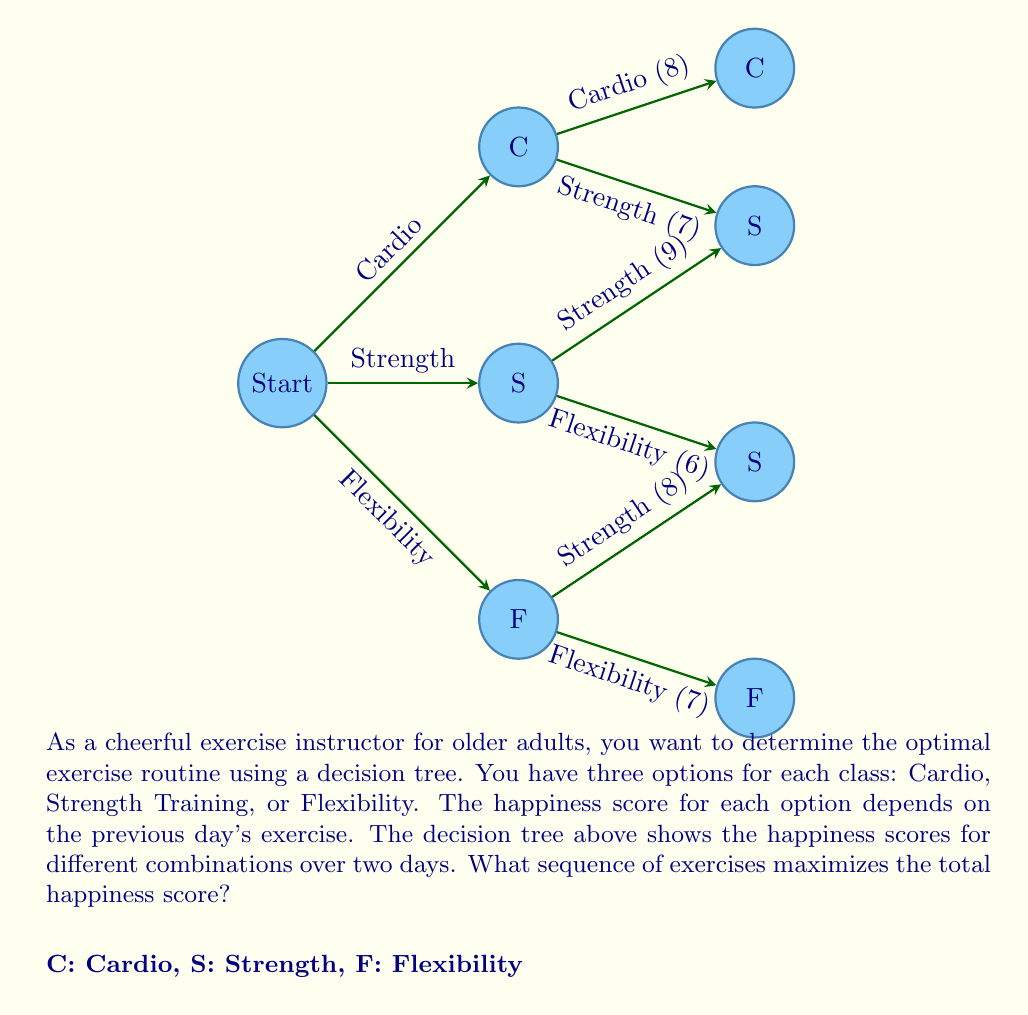Provide a solution to this math problem. To solve this problem, we'll use the decision tree method to find the optimal sequence of exercises that maximizes the total happiness score over two days. We'll work backwards from the end of the tree to the beginning.

Step 1: Identify the final scores for each path.
- Cardio → Cardio: 8
- Cardio → Strength: 7
- Strength → Strength: 9
- Strength → Flexibility: 6
- Flexibility → Strength: 8
- Flexibility → Flexibility: 7

Step 2: Work backwards from each node on day 1.

For Cardio (C) on day 1:
Max(Cardio, Strength) = Max(8, 7) = 8
Best choice after Cardio is Cardio

For Strength (S) on day 1:
Max(Strength, Flexibility) = Max(9, 6) = 9
Best choice after Strength is Strength

For Flexibility (F) on day 1:
Max(Strength, Flexibility) = Max(8, 7) = 8
Best choice after Flexibility is Strength

Step 3: Compare the maximum scores from each starting point.
- Cardio → Cardio: 8
- Strength → Strength: 9
- Flexibility → Strength: 8

Step 4: Choose the highest scoring path.
The highest scoring path is Strength → Strength with a total score of 9.

Therefore, the optimal exercise routine that maximizes the total happiness score is to do Strength Training on both days.
Answer: Strength Training, Strength Training 